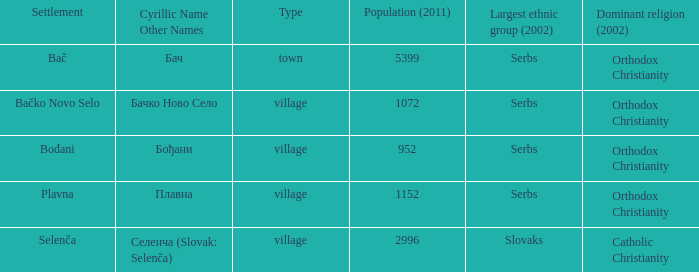In the latin alphabet, how would you represent "плавна"? Plavna. 